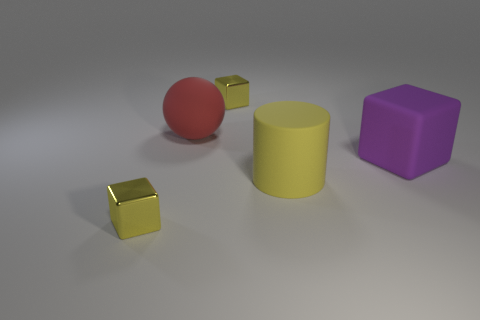Add 2 large purple matte things. How many objects exist? 7 Subtract all spheres. How many objects are left? 4 Add 1 big blocks. How many big blocks exist? 2 Subtract 0 green spheres. How many objects are left? 5 Subtract all tiny yellow metallic cubes. Subtract all red rubber spheres. How many objects are left? 2 Add 3 purple rubber blocks. How many purple rubber blocks are left? 4 